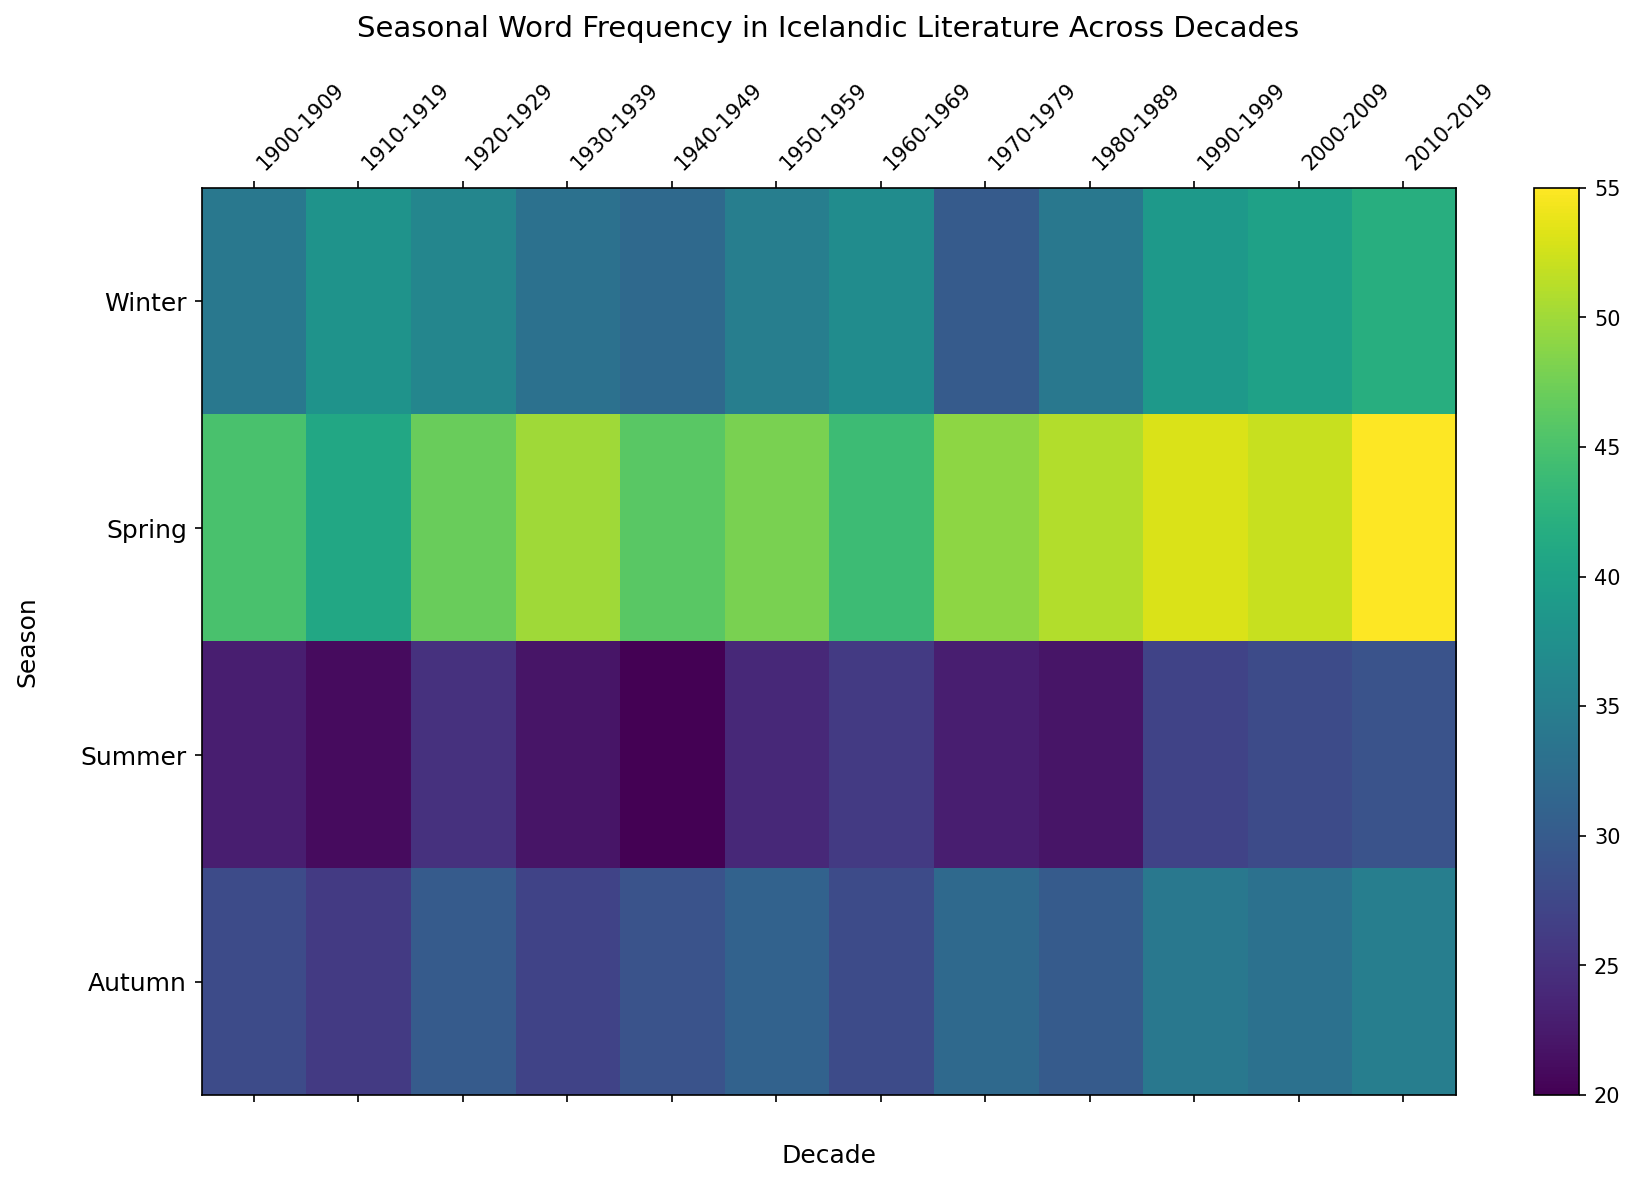What season had the highest frequency of words in the decade 1990-1999? To determine which season had the highest frequency of words in the 1990-1999 decade, look at the color intensity for each season along the 1990-1999 column. The most intense (brightest) color represents the maximum frequency. For the 1990-1999 decade, "Spring" has the brightest color intensity. Thus, Spring has the highest frequency.
Answer: Spring Which decade saw the highest frequency of Winter words? To find the highest frequency of Winter words, look at the intensity of the cells for the 'Winter' row across all decades. Compare these intensities and locate the decade with the brightest color. In this case, the 2010-2019 decade has the highest frequency with a score of 42.
Answer: 2010-2019 What is the total word frequency for all seasons in the decade 2010-2019? Sum the word frequencies of all seasons in the decade 2010-2019. Add Winter (42), Spring (55), Summer (29), and Autumn (35). So, the total frequency is 42 + 55 + 29 + 35 = 161.
Answer: 161 How does the word frequency of Winter in 1900-1909 compare to the word frequency of Summer in the same decade? Compare the word frequency values for Winter and Summer in the 1900-1909 decade. Winter has a value of 34 and Summer has a value of 23. So, Winter has a higher frequency than Summer.
Answer: Winter has a higher frequency What season is most frequently mentioned in the 2000-2009 decade, and by how much more compared to the least mentioned season in the same decade? Identify the season with the highest and lowest frequency in the 2000-2009 decade. Spring has the highest frequency (52) and Summer has the lowest frequency (28). The difference is 52 - 28 = 24.
Answer: Spring by 24 During which decade does Autumn have its peak frequency, and what is that frequency? Look across the 'Autumn' row to find the brightest cell representing the peak frequency. The decade 1990-1999 has the brightest intensity with a value of 34.
Answer: 1990-1999 with a frequency of 34 What is the average word frequency for Summer across all decades? Calculate the average by summing the word frequencies of Summer across all decades and dividing by the total number of decades. The frequencies are 23, 21, 25, 22, 20, 24, 26, 23, 22, 27, 28, 29. Summing these gives 290. Dividing by 12 decades, the average is 290 / 12 ≈ 24.17.
Answer: 24.17 Which decade shows the least frequency for Spring? Look at the 'Spring' row and find the decade with the lowest frequency, represented by the darkest shade. The decade 1910-1919 has the lowest frequency with a value of 41.
Answer: 1910-1919 In which decade does the word frequency for all seasons show a uniform increase without any season decreasing from the previous decade? To find decades with uniform increases, compare the frequencies of each season from one decade to the next. The sequence from 2000-2009 to 2010-2019 shows increases for all seasons: Winter (40 to 42), Spring (52 to 55), Summer (28 to 29), Autumn (33 to 35).
Answer: 2000-2009 to 2010-2019 